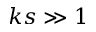Convert formula to latex. <formula><loc_0><loc_0><loc_500><loc_500>k s \gg 1</formula> 